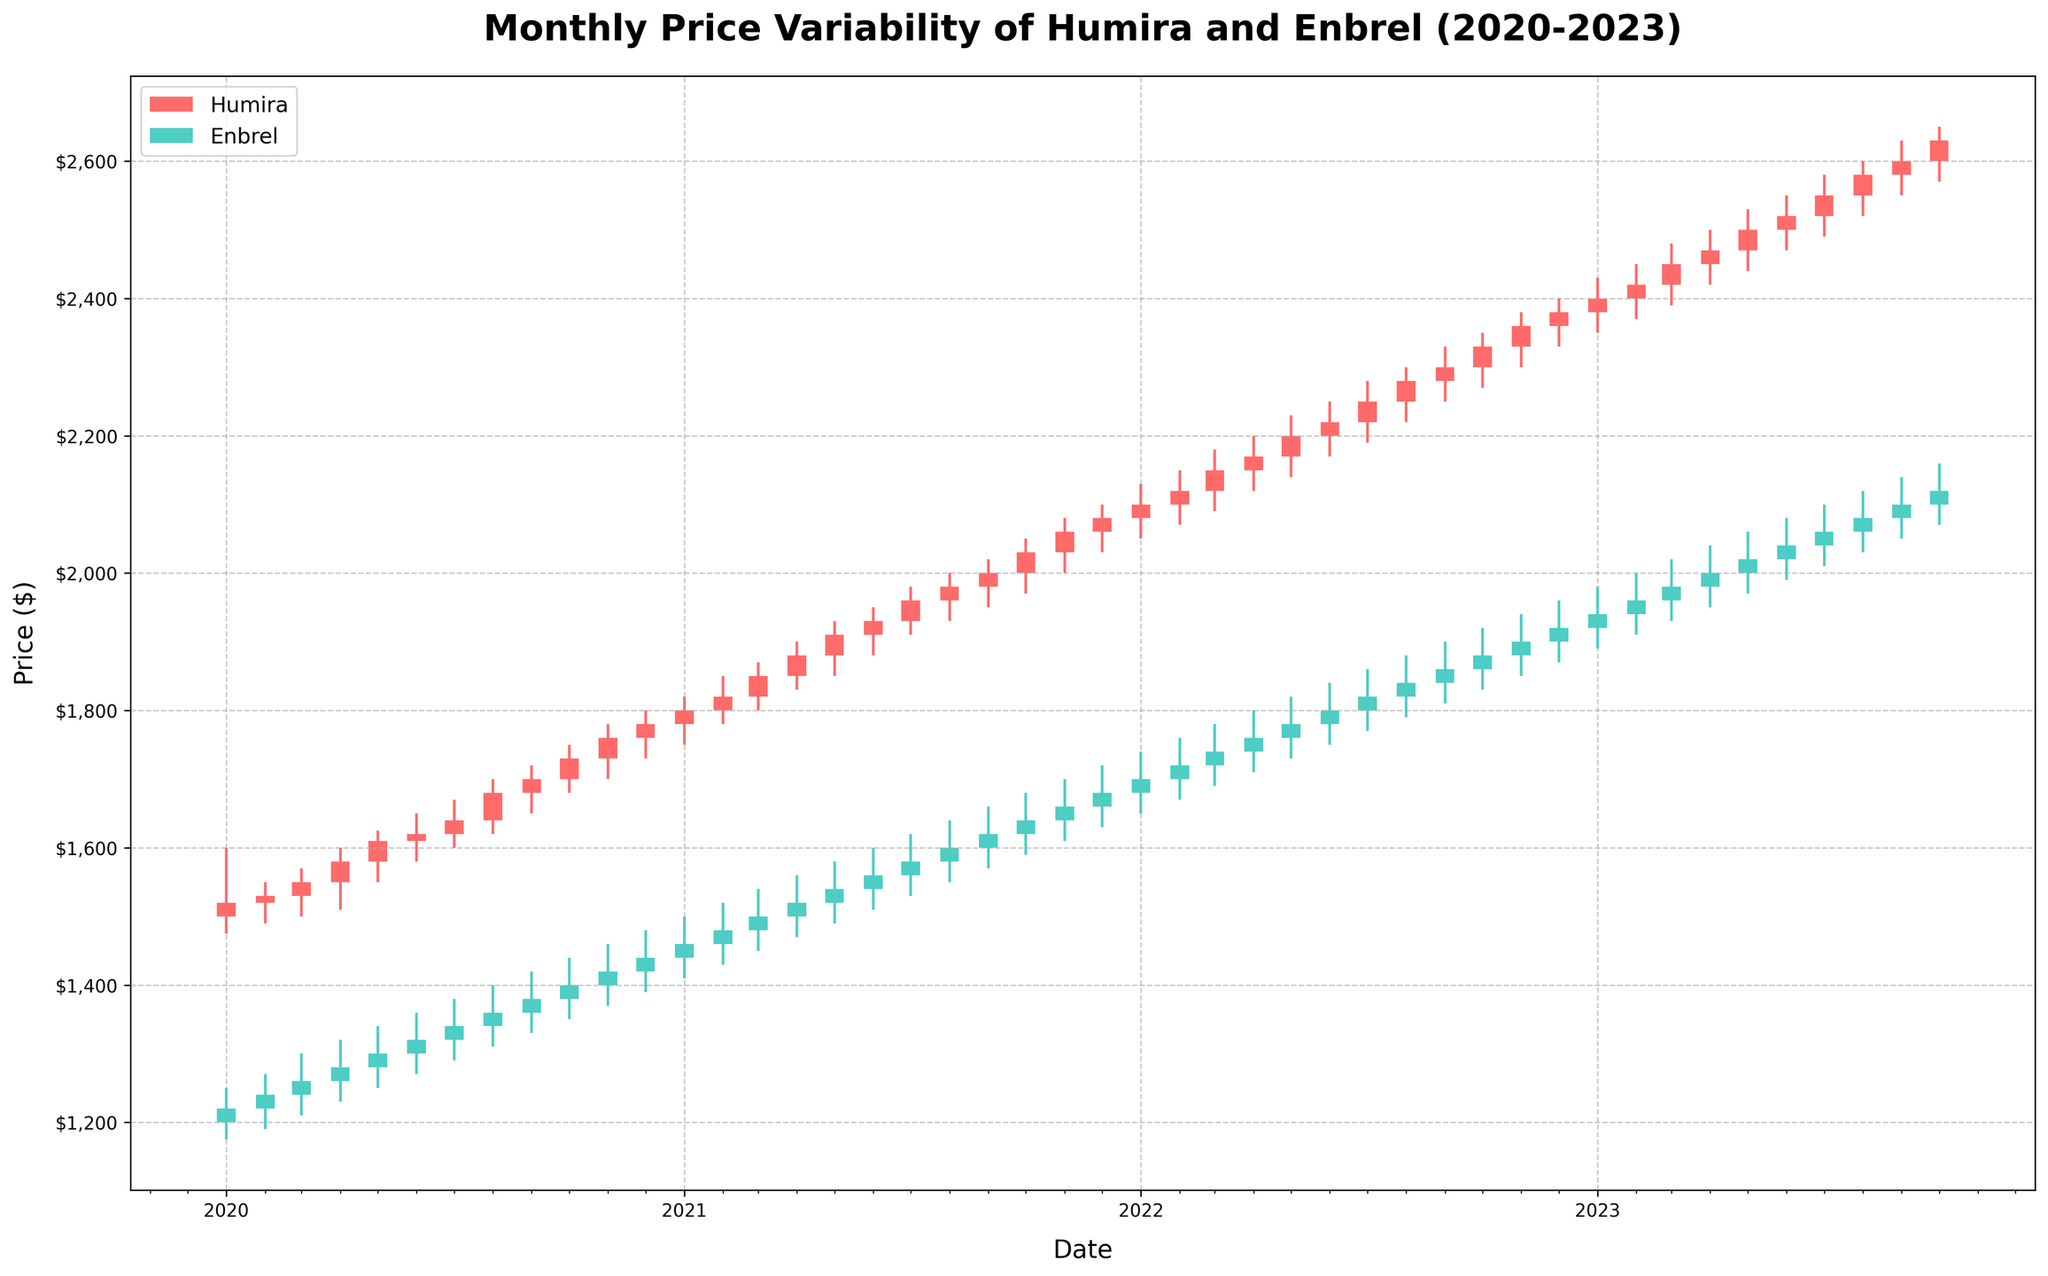Did the closing price of Humira ever decrease compared to the opening price in any month? Observe the candlesticks for Humira; a closing price lower than the opening price results in a "down" candlestick. For example, in March 2020, the closing price was lower than the opening price.
Answer: Yes Which month had the highest variability in price for Enbrel throughout the period? Variability can be assessed by the range (High - Low) for each month. Check each candlestick for Enbrel; April 2023 shows a range of 90 (2040-1950), which is the highest.
Answer: April 2023 What is the average closing price of Humira in 2021? Sum up the closing prices of Humira for each month in 2021 and divide by the number of months (12). The sum (1800+1820+1850+1880+1910+1930+1960+1980+2000+2030+2060+2080) is 23300. The average is 23300/12.
Answer: 1941.67 Which drug showed more consistent price increases over the observed period? Consistency in price increases can be seen by the number of months where closing prices are equal to or higher than the opening prices. Humira's candlesticks show more continuous upward trends than Enbrel.
Answer: Humira By what amount did the closing price of Enbrel change from January 2023 to October 2023? Look at the closing prices of Enbrel in January ($1940) and October ($2120). The change is $2120 - $1940.
Answer: 180 What colors represent Humira and Enbrel in the figure? The colors used for Humira and Enbrel are distinguished in the legend. Humira is represented in red, and Enbrel is represented in teal.
Answer: Red for Humira, teal for Enbrel Which drug had the highest closing price at any point in the observed period? Examine both Humira and Enbrel candlesticks. Humira reached the highest closing price of $2630 in October 2023, whereas Enbrel's highest was $2120.
Answer: Humira Did any month in 2022 see both drugs closing higher than they opened? Look for months where both Humira and Enbrel's closing prices are higher than their opening prices in 2022. For instance, in every month of 2022, both drugs closed higher than they opened.
Answer: Yes 